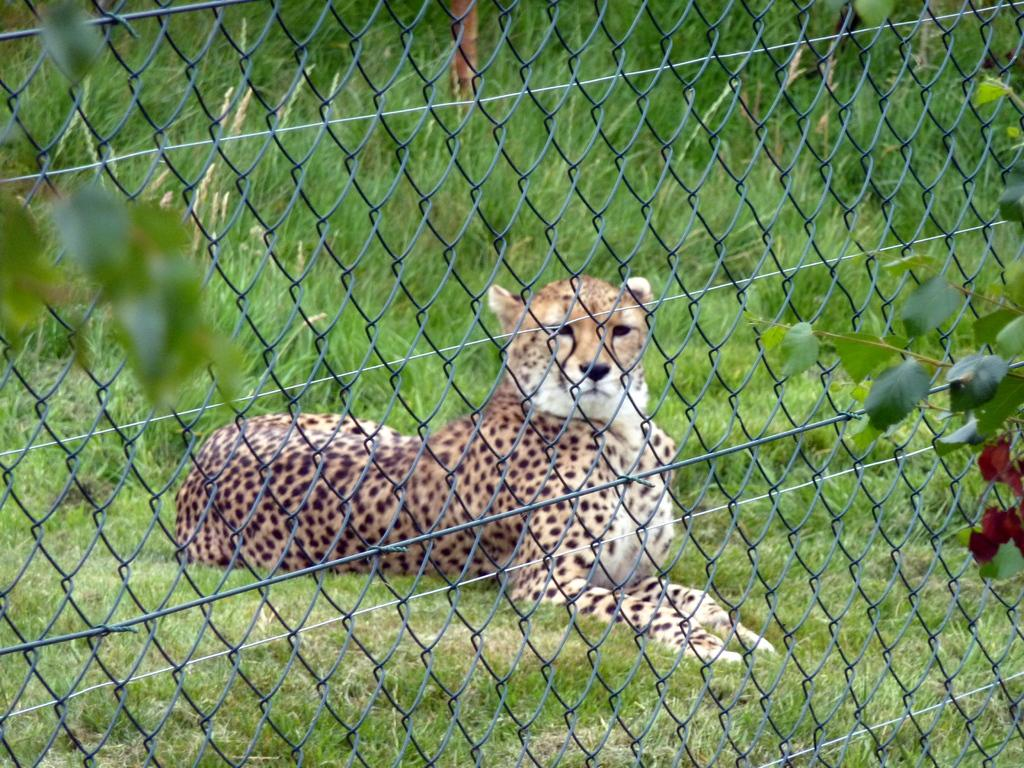What can be seen in the foreground of the image? There is greenery and a fencing in the foreground of the image. What is the cheetah's position in the image? In the background, there is a cheetah sitting on the grass. How many steps can be seen in the image? There are no steps visible in the image. What type of minister is present in the image? There is no minister present in the image. 